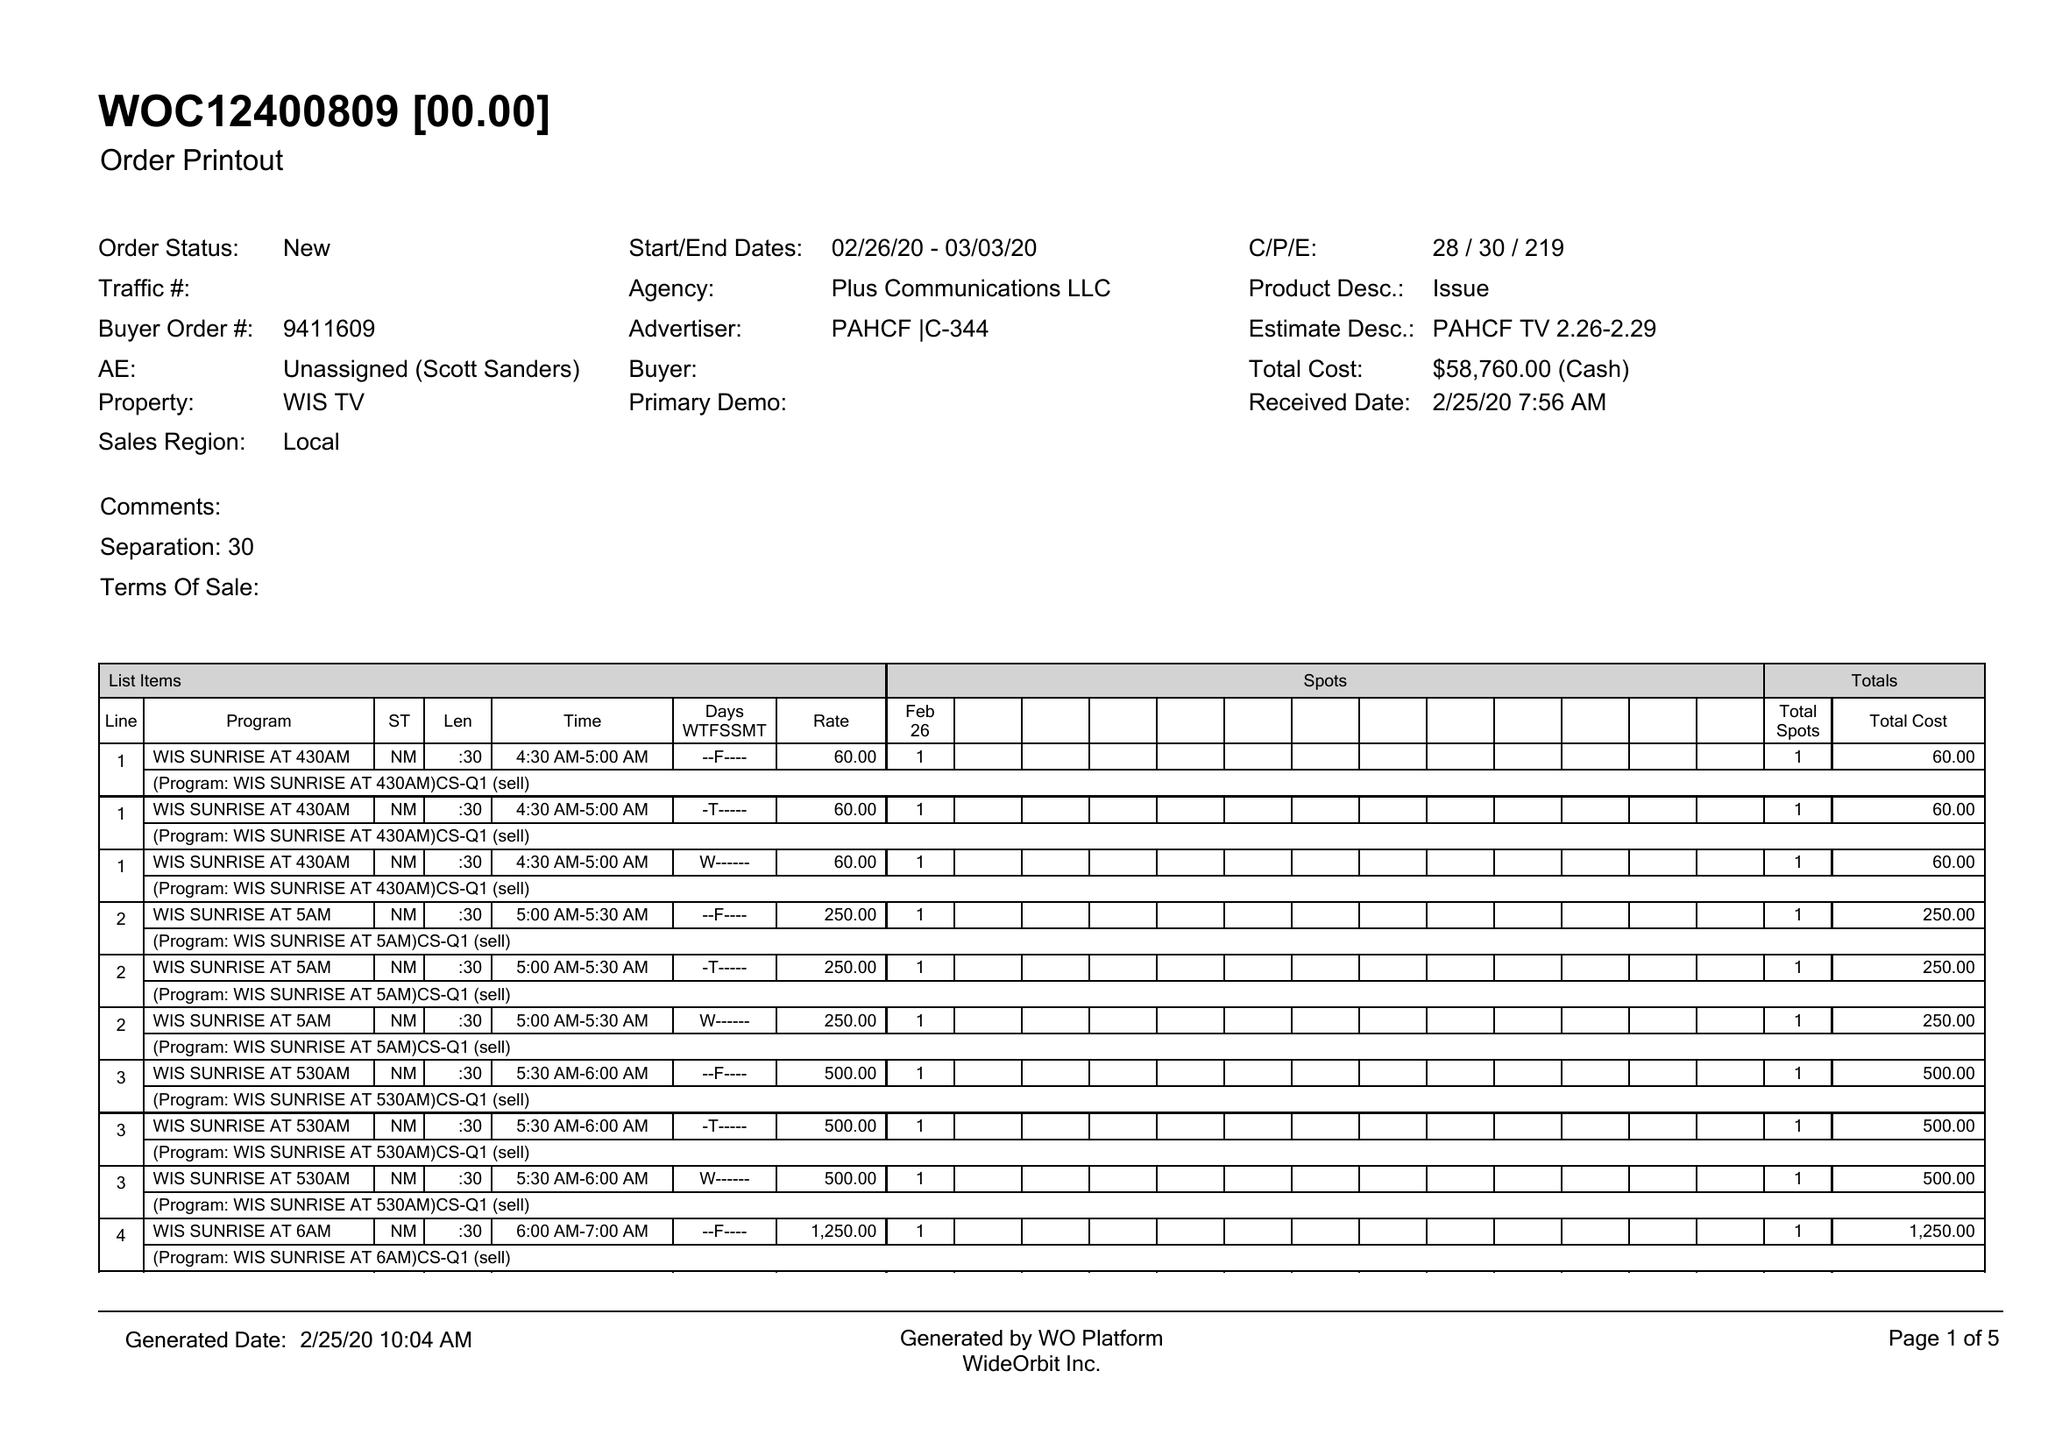What is the value for the contract_num?
Answer the question using a single word or phrase. 9411609 